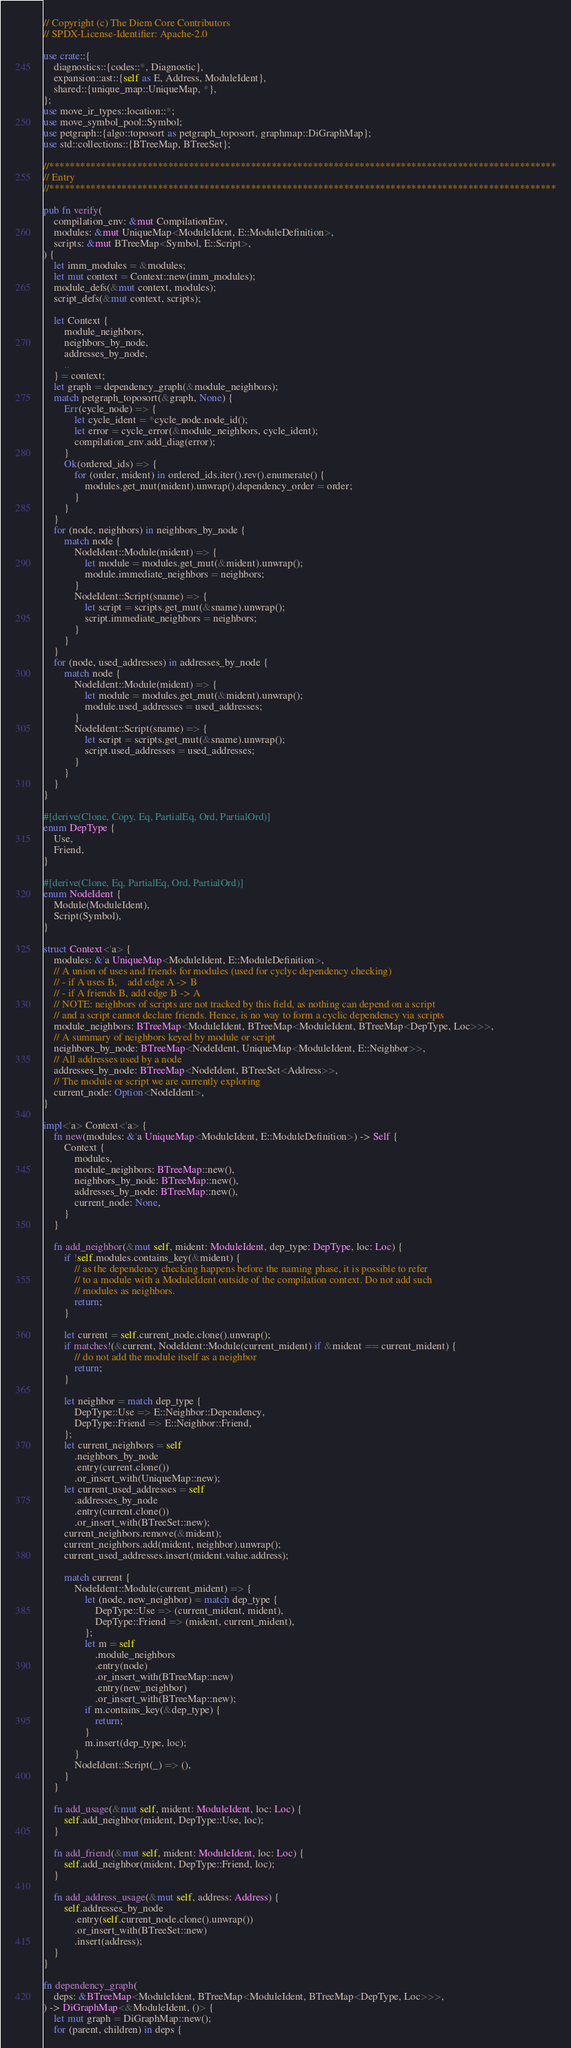Convert code to text. <code><loc_0><loc_0><loc_500><loc_500><_Rust_>// Copyright (c) The Diem Core Contributors
// SPDX-License-Identifier: Apache-2.0

use crate::{
    diagnostics::{codes::*, Diagnostic},
    expansion::ast::{self as E, Address, ModuleIdent},
    shared::{unique_map::UniqueMap, *},
};
use move_ir_types::location::*;
use move_symbol_pool::Symbol;
use petgraph::{algo::toposort as petgraph_toposort, graphmap::DiGraphMap};
use std::collections::{BTreeMap, BTreeSet};

//**************************************************************************************************
// Entry
//**************************************************************************************************

pub fn verify(
    compilation_env: &mut CompilationEnv,
    modules: &mut UniqueMap<ModuleIdent, E::ModuleDefinition>,
    scripts: &mut BTreeMap<Symbol, E::Script>,
) {
    let imm_modules = &modules;
    let mut context = Context::new(imm_modules);
    module_defs(&mut context, modules);
    script_defs(&mut context, scripts);

    let Context {
        module_neighbors,
        neighbors_by_node,
        addresses_by_node,
        ..
    } = context;
    let graph = dependency_graph(&module_neighbors);
    match petgraph_toposort(&graph, None) {
        Err(cycle_node) => {
            let cycle_ident = *cycle_node.node_id();
            let error = cycle_error(&module_neighbors, cycle_ident);
            compilation_env.add_diag(error);
        }
        Ok(ordered_ids) => {
            for (order, mident) in ordered_ids.iter().rev().enumerate() {
                modules.get_mut(mident).unwrap().dependency_order = order;
            }
        }
    }
    for (node, neighbors) in neighbors_by_node {
        match node {
            NodeIdent::Module(mident) => {
                let module = modules.get_mut(&mident).unwrap();
                module.immediate_neighbors = neighbors;
            }
            NodeIdent::Script(sname) => {
                let script = scripts.get_mut(&sname).unwrap();
                script.immediate_neighbors = neighbors;
            }
        }
    }
    for (node, used_addresses) in addresses_by_node {
        match node {
            NodeIdent::Module(mident) => {
                let module = modules.get_mut(&mident).unwrap();
                module.used_addresses = used_addresses;
            }
            NodeIdent::Script(sname) => {
                let script = scripts.get_mut(&sname).unwrap();
                script.used_addresses = used_addresses;
            }
        }
    }
}

#[derive(Clone, Copy, Eq, PartialEq, Ord, PartialOrd)]
enum DepType {
    Use,
    Friend,
}

#[derive(Clone, Eq, PartialEq, Ord, PartialOrd)]
enum NodeIdent {
    Module(ModuleIdent),
    Script(Symbol),
}

struct Context<'a> {
    modules: &'a UniqueMap<ModuleIdent, E::ModuleDefinition>,
    // A union of uses and friends for modules (used for cyclyc dependency checking)
    // - if A uses B,    add edge A -> B
    // - if A friends B, add edge B -> A
    // NOTE: neighbors of scripts are not tracked by this field, as nothing can depend on a script
    // and a script cannot declare friends. Hence, is no way to form a cyclic dependency via scripts
    module_neighbors: BTreeMap<ModuleIdent, BTreeMap<ModuleIdent, BTreeMap<DepType, Loc>>>,
    // A summary of neighbors keyed by module or script
    neighbors_by_node: BTreeMap<NodeIdent, UniqueMap<ModuleIdent, E::Neighbor>>,
    // All addresses used by a node
    addresses_by_node: BTreeMap<NodeIdent, BTreeSet<Address>>,
    // The module or script we are currently exploring
    current_node: Option<NodeIdent>,
}

impl<'a> Context<'a> {
    fn new(modules: &'a UniqueMap<ModuleIdent, E::ModuleDefinition>) -> Self {
        Context {
            modules,
            module_neighbors: BTreeMap::new(),
            neighbors_by_node: BTreeMap::new(),
            addresses_by_node: BTreeMap::new(),
            current_node: None,
        }
    }

    fn add_neighbor(&mut self, mident: ModuleIdent, dep_type: DepType, loc: Loc) {
        if !self.modules.contains_key(&mident) {
            // as the dependency checking happens before the naming phase, it is possible to refer
            // to a module with a ModuleIdent outside of the compilation context. Do not add such
            // modules as neighbors.
            return;
        }

        let current = self.current_node.clone().unwrap();
        if matches!(&current, NodeIdent::Module(current_mident) if &mident == current_mident) {
            // do not add the module itself as a neighbor
            return;
        }

        let neighbor = match dep_type {
            DepType::Use => E::Neighbor::Dependency,
            DepType::Friend => E::Neighbor::Friend,
        };
        let current_neighbors = self
            .neighbors_by_node
            .entry(current.clone())
            .or_insert_with(UniqueMap::new);
        let current_used_addresses = self
            .addresses_by_node
            .entry(current.clone())
            .or_insert_with(BTreeSet::new);
        current_neighbors.remove(&mident);
        current_neighbors.add(mident, neighbor).unwrap();
        current_used_addresses.insert(mident.value.address);

        match current {
            NodeIdent::Module(current_mident) => {
                let (node, new_neighbor) = match dep_type {
                    DepType::Use => (current_mident, mident),
                    DepType::Friend => (mident, current_mident),
                };
                let m = self
                    .module_neighbors
                    .entry(node)
                    .or_insert_with(BTreeMap::new)
                    .entry(new_neighbor)
                    .or_insert_with(BTreeMap::new);
                if m.contains_key(&dep_type) {
                    return;
                }
                m.insert(dep_type, loc);
            }
            NodeIdent::Script(_) => (),
        }
    }

    fn add_usage(&mut self, mident: ModuleIdent, loc: Loc) {
        self.add_neighbor(mident, DepType::Use, loc);
    }

    fn add_friend(&mut self, mident: ModuleIdent, loc: Loc) {
        self.add_neighbor(mident, DepType::Friend, loc);
    }

    fn add_address_usage(&mut self, address: Address) {
        self.addresses_by_node
            .entry(self.current_node.clone().unwrap())
            .or_insert_with(BTreeSet::new)
            .insert(address);
    }
}

fn dependency_graph(
    deps: &BTreeMap<ModuleIdent, BTreeMap<ModuleIdent, BTreeMap<DepType, Loc>>>,
) -> DiGraphMap<&ModuleIdent, ()> {
    let mut graph = DiGraphMap::new();
    for (parent, children) in deps {</code> 